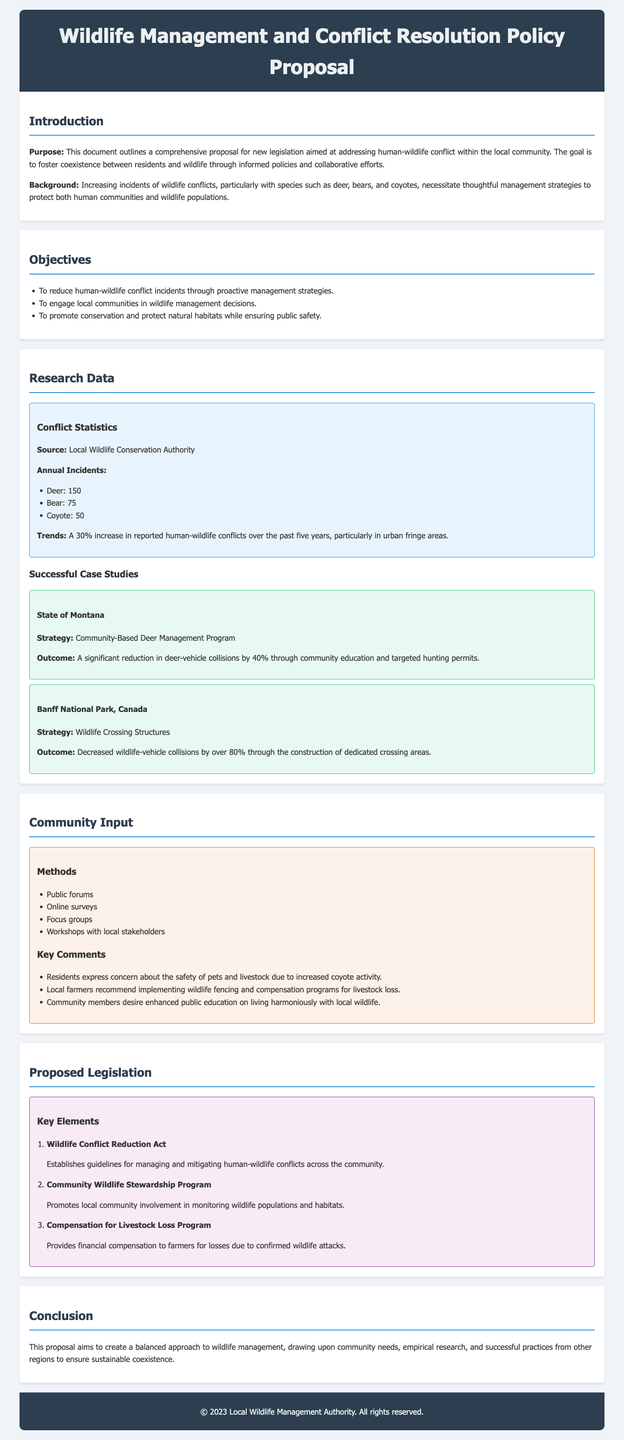What is the purpose of the document? The document outlines a comprehensive proposal for new legislation aimed at addressing human-wildlife conflict within the local community.
Answer: Addressing human-wildlife conflict How many deer-related incidents were reported annually? The document provides specific statistics, indicating the number of deer-related incidents reported.
Answer: 150 What trend was observed in human-wildlife conflicts over the last five years? The document mentions a percentage increase in reported human-wildlife conflicts, highlighting a significant trend.
Answer: 30% increase Which state's community-based program is mentioned as a successful case study? The document references a specific state that implemented a community-based program to manage wildlife conflicts.
Answer: Montana What type of program is recommended for local community involvement? The document specifies a program designed to engage local communities in wildlife management decisions.
Answer: Community Wildlife Stewardship Program What are the key comments from the community about coyote activity? The document includes specific concerns raised by residents regarding interactions with wildlife, particularly coyotes.
Answer: Safety of pets and livestock What compensation program is proposed in the legislation? The document outlines a specific program aimed at providing financial assistance for certain losses experienced by farmers.
Answer: Compensation for Livestock Loss Program What kind of structures were built in Banff National Park to address conflicts? The document provides information on measures taken in another region to mitigate human-wildlife conflicts.
Answer: Wildlife Crossing Structures How many bear-related incidents were reported annually? The document indicates the total number of incidents involving bears, contributing to conflict statistics.
Answer: 75 